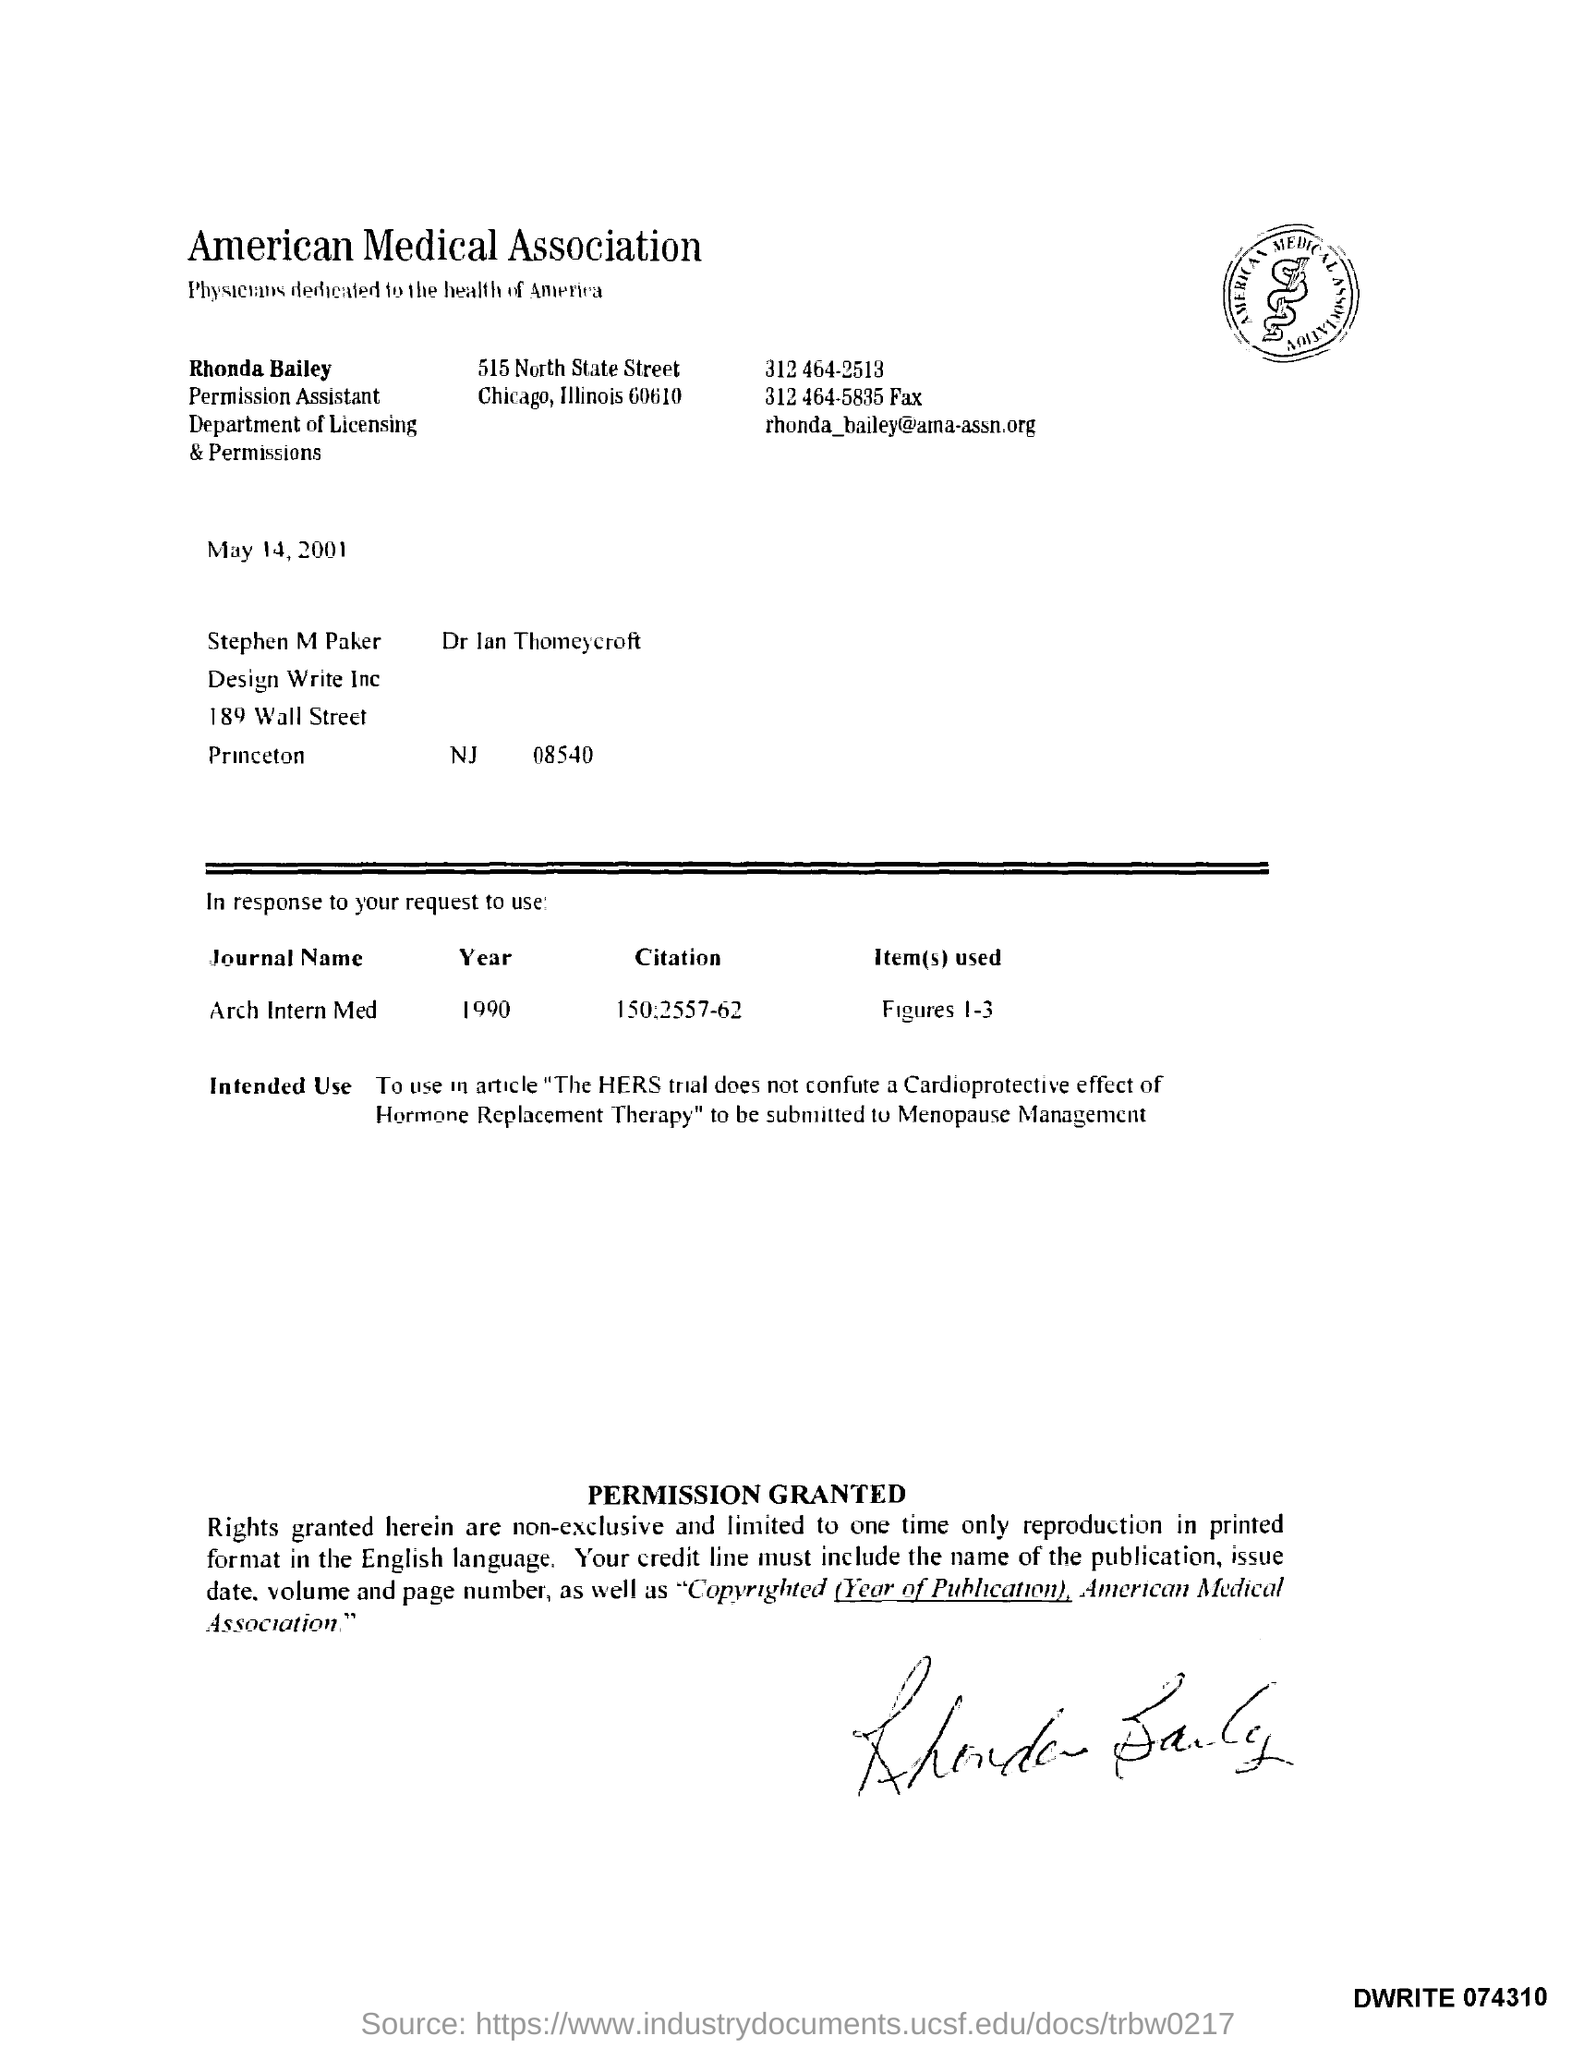Who is the Permission Assistant ?
Keep it short and to the point. Rhonda Bailey. What is the Fax Number ?
Keep it short and to the point. 312 464-5835. What is the Journal Name?
Give a very brief answer. Arch Intern Med. 